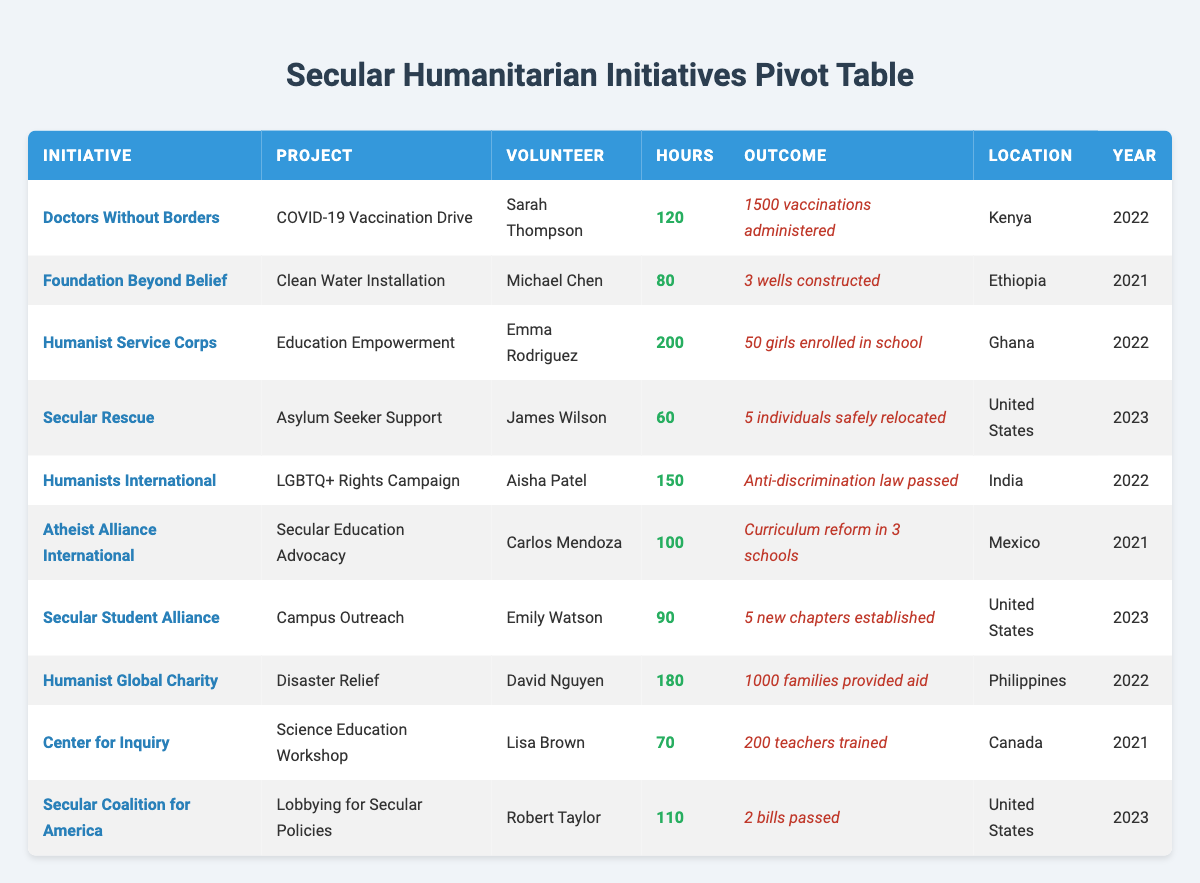What is the total number of volunteer hours recorded in 2022? To find the total volunteer hours in 2022, we need to look at each entry for that year: Doctors Without Borders (120), Humanist Service Corps (200), Humanist Global Charity (180), and Humanists International (150). Adding these together gives us 120 + 200 + 180 + 150 = 650 hours.
Answer: 650 hours Which initiative had the most volunteer hours overall? We can examine the volunteer hours for each initiative: Doctors Without Borders (120), Foundation Beyond Belief (80), Humanist Service Corps (200), Secular Rescue (60), Humanists International (150), Atheist Alliance International (100), Secular Student Alliance (90), Humanist Global Charity (180), Center for Inquiry (70), and Secular Coalition for America (110). The highest is Humanist Service Corps with 200 hours.
Answer: Humanist Service Corps Did any projects result in more than 1000 individuals aided or displaced? Looking at the outcomes, Humanist Global Charity reports "1000 families provided aid," which is the only occurrence exceeding 1000 individuals. Since it specifically states families rather than individuals, we assume it's true.
Answer: Yes What is the average number of volunteer hours for projects in the United States? We have three entries for the United States: Secular Rescue (60), Secular Student Alliance (90), and Secular Coalition for America (110). Calculating the average: (60 + 90 + 110)/3 = 260/3 = approximately 86.67.
Answer: 86.67 In which year did the most significant outcome regarding rights occur and what was it? The outcome "Anti-discrimination law passed" happened in 2022 under Humanists International. To confirm, we check outcomes for 2021 and 2023, none indicate impactful rights outcomes as well. Hence, 2022 is the year of notable rights advancement.
Answer: 2022, Anti-discrimination law passed 